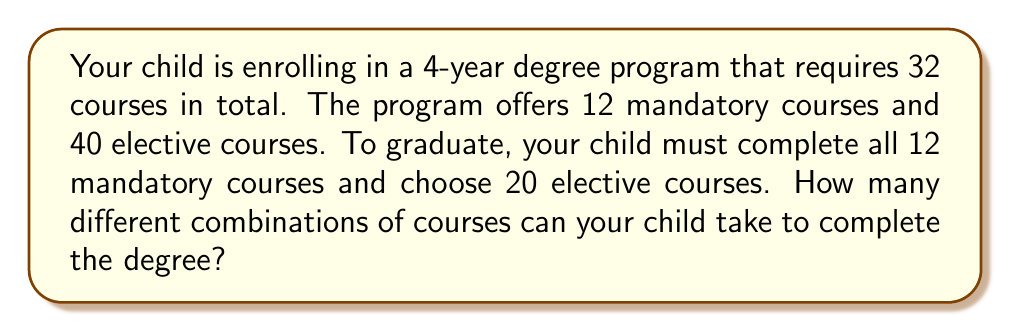Could you help me with this problem? Let's approach this step-by-step:

1) First, we need to understand that the mandatory courses don't contribute to the number of combinations, as they must be taken regardless.

2) The question then becomes: in how many ways can we choose 20 elective courses out of 40?

3) This is a combination problem. We're selecting 20 items out of 40, where the order doesn't matter (it doesn't matter in which order the courses are taken).

4) The formula for combinations is:

   $$C(n,r) = \frac{n!}{r!(n-r)!}$$

   where $n$ is the total number of items to choose from, and $r$ is the number of items being chosen.

5) In this case, $n = 40$ (total elective courses) and $r = 20$ (elective courses to be taken).

6) Plugging these numbers into the formula:

   $$C(40,20) = \frac{40!}{20!(40-20)!} = \frac{40!}{20!20!}$$

7) Calculating this:
   
   $$\frac{40!}{20!20!} = 137,846,528,820$$

Therefore, there are 137,846,528,820 different combinations of courses your child can take to complete the degree.
Answer: 137,846,528,820 